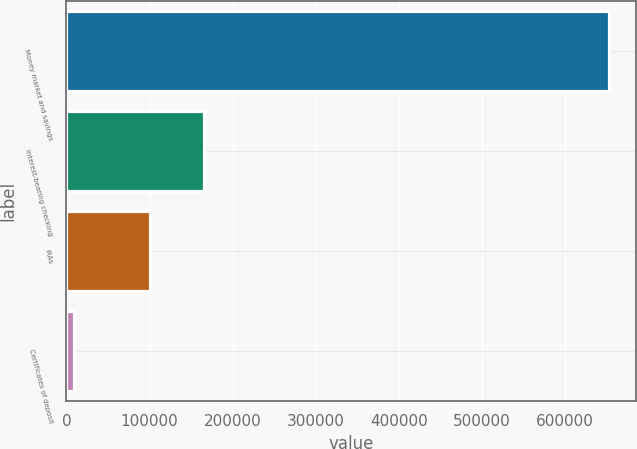Convert chart. <chart><loc_0><loc_0><loc_500><loc_500><bar_chart><fcel>Money market and savings<fcel>Interest-bearing checking<fcel>IRAs<fcel>Certificates of deposit<nl><fcel>653126<fcel>165468<fcel>101085<fcel>9297<nl></chart> 